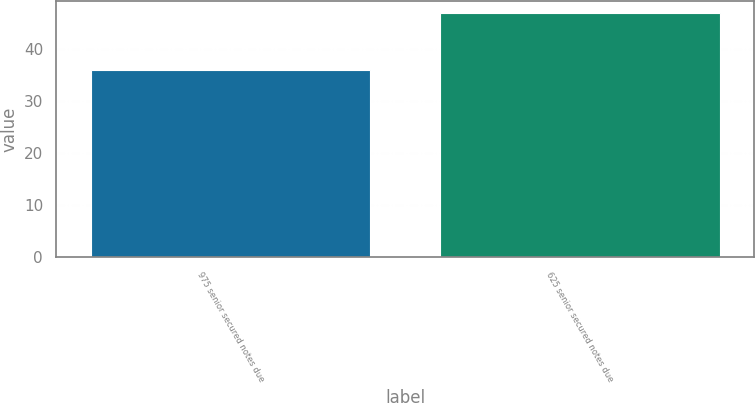Convert chart to OTSL. <chart><loc_0><loc_0><loc_500><loc_500><bar_chart><fcel>975 senior secured notes due<fcel>625 senior secured notes due<nl><fcel>36<fcel>47<nl></chart> 